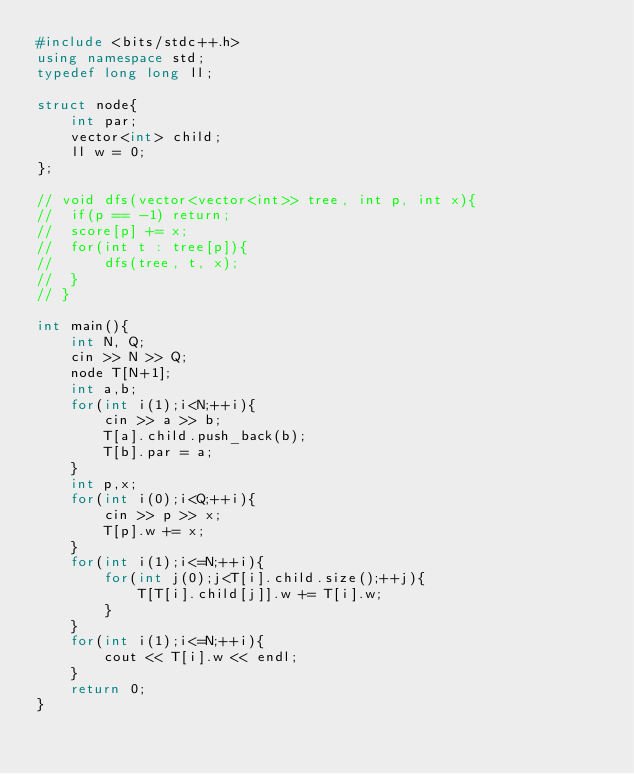Convert code to text. <code><loc_0><loc_0><loc_500><loc_500><_C++_>#include <bits/stdc++.h>
using namespace std;
typedef long long ll;

struct node{
    int par;
	vector<int> child;
	ll w = 0;
};

// void dfs(vector<vector<int>> tree, int p, int x){
// 	if(p == -1) return;
// 	score[p] += x;
// 	for(int t : tree[p]){
// 		dfs(tree, t, x);
// 	}
// }

int main(){
	int N, Q;
	cin >> N >> Q;
	node T[N+1];
	int a,b;
	for(int i(1);i<N;++i){
		cin >> a >> b;
		T[a].child.push_back(b);
		T[b].par = a;
	}
	int p,x;
	for(int i(0);i<Q;++i){
		cin >> p >> x;
		T[p].w += x;
	}
	for(int i(1);i<=N;++i){
		for(int j(0);j<T[i].child.size();++j){
			T[T[i].child[j]].w += T[i].w;
		}
	}
	for(int i(1);i<=N;++i){
		cout << T[i].w << endl;
	}
	return 0;
}</code> 